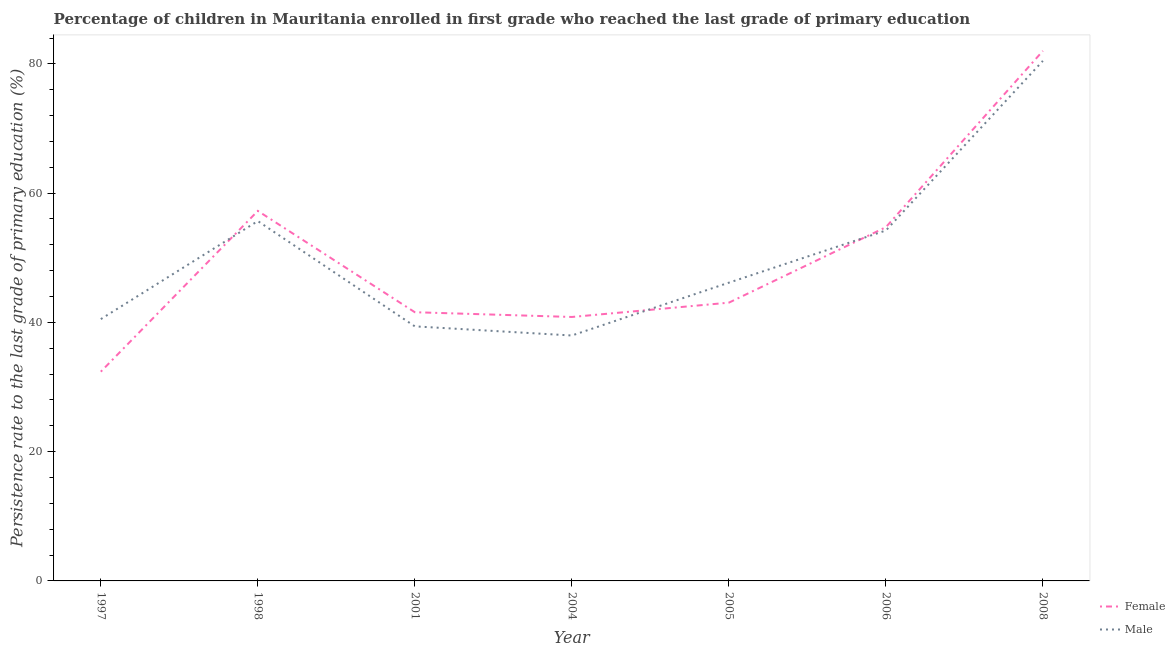What is the persistence rate of male students in 1997?
Make the answer very short. 40.51. Across all years, what is the maximum persistence rate of female students?
Your answer should be very brief. 82.01. Across all years, what is the minimum persistence rate of female students?
Your answer should be compact. 32.38. What is the total persistence rate of female students in the graph?
Your answer should be very brief. 351.83. What is the difference between the persistence rate of female students in 1998 and that in 2005?
Provide a short and direct response. 14.2. What is the difference between the persistence rate of female students in 1997 and the persistence rate of male students in 2008?
Ensure brevity in your answer.  -48.09. What is the average persistence rate of male students per year?
Offer a very short reply. 50.63. In the year 1997, what is the difference between the persistence rate of female students and persistence rate of male students?
Offer a terse response. -8.13. In how many years, is the persistence rate of female students greater than 28 %?
Your response must be concise. 7. What is the ratio of the persistence rate of male students in 1997 to that in 2006?
Offer a terse response. 0.75. Is the persistence rate of female students in 2005 less than that in 2006?
Your response must be concise. Yes. Is the difference between the persistence rate of male students in 2005 and 2006 greater than the difference between the persistence rate of female students in 2005 and 2006?
Provide a succinct answer. Yes. What is the difference between the highest and the second highest persistence rate of male students?
Make the answer very short. 24.79. What is the difference between the highest and the lowest persistence rate of male students?
Offer a terse response. 42.49. In how many years, is the persistence rate of female students greater than the average persistence rate of female students taken over all years?
Your answer should be very brief. 3. Does the persistence rate of male students monotonically increase over the years?
Provide a succinct answer. No. Is the persistence rate of male students strictly less than the persistence rate of female students over the years?
Your answer should be compact. No. How many lines are there?
Your answer should be compact. 2. How many years are there in the graph?
Give a very brief answer. 7. Does the graph contain any zero values?
Your response must be concise. No. Where does the legend appear in the graph?
Give a very brief answer. Bottom right. How are the legend labels stacked?
Your answer should be compact. Vertical. What is the title of the graph?
Your response must be concise. Percentage of children in Mauritania enrolled in first grade who reached the last grade of primary education. What is the label or title of the Y-axis?
Provide a succinct answer. Persistence rate to the last grade of primary education (%). What is the Persistence rate to the last grade of primary education (%) in Female in 1997?
Ensure brevity in your answer.  32.38. What is the Persistence rate to the last grade of primary education (%) of Male in 1997?
Ensure brevity in your answer.  40.51. What is the Persistence rate to the last grade of primary education (%) in Female in 1998?
Your response must be concise. 57.25. What is the Persistence rate to the last grade of primary education (%) in Male in 1998?
Your response must be concise. 55.68. What is the Persistence rate to the last grade of primary education (%) in Female in 2001?
Provide a succinct answer. 41.57. What is the Persistence rate to the last grade of primary education (%) in Male in 2001?
Make the answer very short. 39.39. What is the Persistence rate to the last grade of primary education (%) of Female in 2004?
Your response must be concise. 40.84. What is the Persistence rate to the last grade of primary education (%) in Male in 2004?
Give a very brief answer. 37.97. What is the Persistence rate to the last grade of primary education (%) in Female in 2005?
Provide a succinct answer. 43.05. What is the Persistence rate to the last grade of primary education (%) of Male in 2005?
Keep it short and to the point. 46.14. What is the Persistence rate to the last grade of primary education (%) of Female in 2006?
Offer a terse response. 54.73. What is the Persistence rate to the last grade of primary education (%) in Male in 2006?
Make the answer very short. 54.22. What is the Persistence rate to the last grade of primary education (%) in Female in 2008?
Give a very brief answer. 82.01. What is the Persistence rate to the last grade of primary education (%) of Male in 2008?
Your answer should be compact. 80.47. Across all years, what is the maximum Persistence rate to the last grade of primary education (%) of Female?
Make the answer very short. 82.01. Across all years, what is the maximum Persistence rate to the last grade of primary education (%) in Male?
Offer a very short reply. 80.47. Across all years, what is the minimum Persistence rate to the last grade of primary education (%) of Female?
Offer a terse response. 32.38. Across all years, what is the minimum Persistence rate to the last grade of primary education (%) of Male?
Offer a very short reply. 37.97. What is the total Persistence rate to the last grade of primary education (%) in Female in the graph?
Your answer should be very brief. 351.83. What is the total Persistence rate to the last grade of primary education (%) of Male in the graph?
Provide a succinct answer. 354.38. What is the difference between the Persistence rate to the last grade of primary education (%) in Female in 1997 and that in 1998?
Your answer should be very brief. -24.88. What is the difference between the Persistence rate to the last grade of primary education (%) in Male in 1997 and that in 1998?
Give a very brief answer. -15.17. What is the difference between the Persistence rate to the last grade of primary education (%) of Female in 1997 and that in 2001?
Give a very brief answer. -9.2. What is the difference between the Persistence rate to the last grade of primary education (%) in Male in 1997 and that in 2001?
Your answer should be compact. 1.12. What is the difference between the Persistence rate to the last grade of primary education (%) of Female in 1997 and that in 2004?
Make the answer very short. -8.46. What is the difference between the Persistence rate to the last grade of primary education (%) in Male in 1997 and that in 2004?
Keep it short and to the point. 2.54. What is the difference between the Persistence rate to the last grade of primary education (%) of Female in 1997 and that in 2005?
Give a very brief answer. -10.68. What is the difference between the Persistence rate to the last grade of primary education (%) in Male in 1997 and that in 2005?
Your response must be concise. -5.64. What is the difference between the Persistence rate to the last grade of primary education (%) of Female in 1997 and that in 2006?
Ensure brevity in your answer.  -22.36. What is the difference between the Persistence rate to the last grade of primary education (%) in Male in 1997 and that in 2006?
Keep it short and to the point. -13.71. What is the difference between the Persistence rate to the last grade of primary education (%) of Female in 1997 and that in 2008?
Offer a very short reply. -49.63. What is the difference between the Persistence rate to the last grade of primary education (%) in Male in 1997 and that in 2008?
Provide a short and direct response. -39.96. What is the difference between the Persistence rate to the last grade of primary education (%) in Female in 1998 and that in 2001?
Offer a very short reply. 15.68. What is the difference between the Persistence rate to the last grade of primary education (%) of Male in 1998 and that in 2001?
Your answer should be compact. 16.29. What is the difference between the Persistence rate to the last grade of primary education (%) in Female in 1998 and that in 2004?
Your response must be concise. 16.41. What is the difference between the Persistence rate to the last grade of primary education (%) in Male in 1998 and that in 2004?
Your answer should be very brief. 17.71. What is the difference between the Persistence rate to the last grade of primary education (%) of Female in 1998 and that in 2005?
Your response must be concise. 14.2. What is the difference between the Persistence rate to the last grade of primary education (%) of Male in 1998 and that in 2005?
Give a very brief answer. 9.53. What is the difference between the Persistence rate to the last grade of primary education (%) of Female in 1998 and that in 2006?
Your response must be concise. 2.52. What is the difference between the Persistence rate to the last grade of primary education (%) in Male in 1998 and that in 2006?
Your answer should be compact. 1.46. What is the difference between the Persistence rate to the last grade of primary education (%) of Female in 1998 and that in 2008?
Offer a terse response. -24.75. What is the difference between the Persistence rate to the last grade of primary education (%) of Male in 1998 and that in 2008?
Offer a very short reply. -24.79. What is the difference between the Persistence rate to the last grade of primary education (%) of Female in 2001 and that in 2004?
Provide a short and direct response. 0.74. What is the difference between the Persistence rate to the last grade of primary education (%) in Male in 2001 and that in 2004?
Offer a very short reply. 1.41. What is the difference between the Persistence rate to the last grade of primary education (%) in Female in 2001 and that in 2005?
Provide a succinct answer. -1.48. What is the difference between the Persistence rate to the last grade of primary education (%) in Male in 2001 and that in 2005?
Give a very brief answer. -6.76. What is the difference between the Persistence rate to the last grade of primary education (%) of Female in 2001 and that in 2006?
Make the answer very short. -13.16. What is the difference between the Persistence rate to the last grade of primary education (%) of Male in 2001 and that in 2006?
Keep it short and to the point. -14.83. What is the difference between the Persistence rate to the last grade of primary education (%) in Female in 2001 and that in 2008?
Your response must be concise. -40.43. What is the difference between the Persistence rate to the last grade of primary education (%) of Male in 2001 and that in 2008?
Keep it short and to the point. -41.08. What is the difference between the Persistence rate to the last grade of primary education (%) in Female in 2004 and that in 2005?
Your answer should be very brief. -2.21. What is the difference between the Persistence rate to the last grade of primary education (%) in Male in 2004 and that in 2005?
Keep it short and to the point. -8.17. What is the difference between the Persistence rate to the last grade of primary education (%) of Female in 2004 and that in 2006?
Keep it short and to the point. -13.89. What is the difference between the Persistence rate to the last grade of primary education (%) of Male in 2004 and that in 2006?
Offer a terse response. -16.25. What is the difference between the Persistence rate to the last grade of primary education (%) in Female in 2004 and that in 2008?
Provide a short and direct response. -41.17. What is the difference between the Persistence rate to the last grade of primary education (%) of Male in 2004 and that in 2008?
Your answer should be very brief. -42.49. What is the difference between the Persistence rate to the last grade of primary education (%) of Female in 2005 and that in 2006?
Give a very brief answer. -11.68. What is the difference between the Persistence rate to the last grade of primary education (%) of Male in 2005 and that in 2006?
Make the answer very short. -8.08. What is the difference between the Persistence rate to the last grade of primary education (%) in Female in 2005 and that in 2008?
Provide a short and direct response. -38.95. What is the difference between the Persistence rate to the last grade of primary education (%) of Male in 2005 and that in 2008?
Your response must be concise. -34.32. What is the difference between the Persistence rate to the last grade of primary education (%) of Female in 2006 and that in 2008?
Provide a succinct answer. -27.27. What is the difference between the Persistence rate to the last grade of primary education (%) of Male in 2006 and that in 2008?
Your response must be concise. -26.25. What is the difference between the Persistence rate to the last grade of primary education (%) of Female in 1997 and the Persistence rate to the last grade of primary education (%) of Male in 1998?
Your response must be concise. -23.3. What is the difference between the Persistence rate to the last grade of primary education (%) of Female in 1997 and the Persistence rate to the last grade of primary education (%) of Male in 2001?
Offer a very short reply. -7.01. What is the difference between the Persistence rate to the last grade of primary education (%) in Female in 1997 and the Persistence rate to the last grade of primary education (%) in Male in 2004?
Your answer should be compact. -5.6. What is the difference between the Persistence rate to the last grade of primary education (%) in Female in 1997 and the Persistence rate to the last grade of primary education (%) in Male in 2005?
Give a very brief answer. -13.77. What is the difference between the Persistence rate to the last grade of primary education (%) in Female in 1997 and the Persistence rate to the last grade of primary education (%) in Male in 2006?
Provide a succinct answer. -21.84. What is the difference between the Persistence rate to the last grade of primary education (%) of Female in 1997 and the Persistence rate to the last grade of primary education (%) of Male in 2008?
Your answer should be very brief. -48.09. What is the difference between the Persistence rate to the last grade of primary education (%) in Female in 1998 and the Persistence rate to the last grade of primary education (%) in Male in 2001?
Your answer should be very brief. 17.86. What is the difference between the Persistence rate to the last grade of primary education (%) in Female in 1998 and the Persistence rate to the last grade of primary education (%) in Male in 2004?
Keep it short and to the point. 19.28. What is the difference between the Persistence rate to the last grade of primary education (%) in Female in 1998 and the Persistence rate to the last grade of primary education (%) in Male in 2005?
Ensure brevity in your answer.  11.11. What is the difference between the Persistence rate to the last grade of primary education (%) of Female in 1998 and the Persistence rate to the last grade of primary education (%) of Male in 2006?
Offer a terse response. 3.03. What is the difference between the Persistence rate to the last grade of primary education (%) in Female in 1998 and the Persistence rate to the last grade of primary education (%) in Male in 2008?
Your response must be concise. -23.21. What is the difference between the Persistence rate to the last grade of primary education (%) in Female in 2001 and the Persistence rate to the last grade of primary education (%) in Male in 2004?
Offer a terse response. 3.6. What is the difference between the Persistence rate to the last grade of primary education (%) in Female in 2001 and the Persistence rate to the last grade of primary education (%) in Male in 2005?
Offer a terse response. -4.57. What is the difference between the Persistence rate to the last grade of primary education (%) in Female in 2001 and the Persistence rate to the last grade of primary education (%) in Male in 2006?
Your response must be concise. -12.65. What is the difference between the Persistence rate to the last grade of primary education (%) in Female in 2001 and the Persistence rate to the last grade of primary education (%) in Male in 2008?
Your answer should be very brief. -38.89. What is the difference between the Persistence rate to the last grade of primary education (%) of Female in 2004 and the Persistence rate to the last grade of primary education (%) of Male in 2005?
Provide a short and direct response. -5.31. What is the difference between the Persistence rate to the last grade of primary education (%) of Female in 2004 and the Persistence rate to the last grade of primary education (%) of Male in 2006?
Offer a terse response. -13.38. What is the difference between the Persistence rate to the last grade of primary education (%) in Female in 2004 and the Persistence rate to the last grade of primary education (%) in Male in 2008?
Your answer should be compact. -39.63. What is the difference between the Persistence rate to the last grade of primary education (%) in Female in 2005 and the Persistence rate to the last grade of primary education (%) in Male in 2006?
Ensure brevity in your answer.  -11.17. What is the difference between the Persistence rate to the last grade of primary education (%) in Female in 2005 and the Persistence rate to the last grade of primary education (%) in Male in 2008?
Provide a succinct answer. -37.41. What is the difference between the Persistence rate to the last grade of primary education (%) of Female in 2006 and the Persistence rate to the last grade of primary education (%) of Male in 2008?
Your answer should be very brief. -25.73. What is the average Persistence rate to the last grade of primary education (%) in Female per year?
Ensure brevity in your answer.  50.26. What is the average Persistence rate to the last grade of primary education (%) of Male per year?
Give a very brief answer. 50.63. In the year 1997, what is the difference between the Persistence rate to the last grade of primary education (%) of Female and Persistence rate to the last grade of primary education (%) of Male?
Your response must be concise. -8.13. In the year 1998, what is the difference between the Persistence rate to the last grade of primary education (%) in Female and Persistence rate to the last grade of primary education (%) in Male?
Your answer should be very brief. 1.57. In the year 2001, what is the difference between the Persistence rate to the last grade of primary education (%) of Female and Persistence rate to the last grade of primary education (%) of Male?
Your answer should be compact. 2.19. In the year 2004, what is the difference between the Persistence rate to the last grade of primary education (%) in Female and Persistence rate to the last grade of primary education (%) in Male?
Keep it short and to the point. 2.87. In the year 2005, what is the difference between the Persistence rate to the last grade of primary education (%) in Female and Persistence rate to the last grade of primary education (%) in Male?
Your answer should be compact. -3.09. In the year 2006, what is the difference between the Persistence rate to the last grade of primary education (%) of Female and Persistence rate to the last grade of primary education (%) of Male?
Make the answer very short. 0.51. In the year 2008, what is the difference between the Persistence rate to the last grade of primary education (%) in Female and Persistence rate to the last grade of primary education (%) in Male?
Your response must be concise. 1.54. What is the ratio of the Persistence rate to the last grade of primary education (%) of Female in 1997 to that in 1998?
Provide a succinct answer. 0.57. What is the ratio of the Persistence rate to the last grade of primary education (%) in Male in 1997 to that in 1998?
Offer a very short reply. 0.73. What is the ratio of the Persistence rate to the last grade of primary education (%) in Female in 1997 to that in 2001?
Make the answer very short. 0.78. What is the ratio of the Persistence rate to the last grade of primary education (%) in Male in 1997 to that in 2001?
Provide a succinct answer. 1.03. What is the ratio of the Persistence rate to the last grade of primary education (%) in Female in 1997 to that in 2004?
Keep it short and to the point. 0.79. What is the ratio of the Persistence rate to the last grade of primary education (%) in Male in 1997 to that in 2004?
Ensure brevity in your answer.  1.07. What is the ratio of the Persistence rate to the last grade of primary education (%) of Female in 1997 to that in 2005?
Your answer should be compact. 0.75. What is the ratio of the Persistence rate to the last grade of primary education (%) in Male in 1997 to that in 2005?
Make the answer very short. 0.88. What is the ratio of the Persistence rate to the last grade of primary education (%) of Female in 1997 to that in 2006?
Provide a succinct answer. 0.59. What is the ratio of the Persistence rate to the last grade of primary education (%) of Male in 1997 to that in 2006?
Your response must be concise. 0.75. What is the ratio of the Persistence rate to the last grade of primary education (%) in Female in 1997 to that in 2008?
Your answer should be compact. 0.39. What is the ratio of the Persistence rate to the last grade of primary education (%) in Male in 1997 to that in 2008?
Your response must be concise. 0.5. What is the ratio of the Persistence rate to the last grade of primary education (%) in Female in 1998 to that in 2001?
Offer a very short reply. 1.38. What is the ratio of the Persistence rate to the last grade of primary education (%) in Male in 1998 to that in 2001?
Provide a short and direct response. 1.41. What is the ratio of the Persistence rate to the last grade of primary education (%) in Female in 1998 to that in 2004?
Provide a short and direct response. 1.4. What is the ratio of the Persistence rate to the last grade of primary education (%) of Male in 1998 to that in 2004?
Provide a succinct answer. 1.47. What is the ratio of the Persistence rate to the last grade of primary education (%) in Female in 1998 to that in 2005?
Your response must be concise. 1.33. What is the ratio of the Persistence rate to the last grade of primary education (%) of Male in 1998 to that in 2005?
Give a very brief answer. 1.21. What is the ratio of the Persistence rate to the last grade of primary education (%) in Female in 1998 to that in 2006?
Make the answer very short. 1.05. What is the ratio of the Persistence rate to the last grade of primary education (%) in Male in 1998 to that in 2006?
Provide a short and direct response. 1.03. What is the ratio of the Persistence rate to the last grade of primary education (%) of Female in 1998 to that in 2008?
Provide a succinct answer. 0.7. What is the ratio of the Persistence rate to the last grade of primary education (%) in Male in 1998 to that in 2008?
Your answer should be compact. 0.69. What is the ratio of the Persistence rate to the last grade of primary education (%) in Female in 2001 to that in 2004?
Offer a very short reply. 1.02. What is the ratio of the Persistence rate to the last grade of primary education (%) of Male in 2001 to that in 2004?
Provide a succinct answer. 1.04. What is the ratio of the Persistence rate to the last grade of primary education (%) in Female in 2001 to that in 2005?
Keep it short and to the point. 0.97. What is the ratio of the Persistence rate to the last grade of primary education (%) of Male in 2001 to that in 2005?
Make the answer very short. 0.85. What is the ratio of the Persistence rate to the last grade of primary education (%) in Female in 2001 to that in 2006?
Offer a terse response. 0.76. What is the ratio of the Persistence rate to the last grade of primary education (%) in Male in 2001 to that in 2006?
Your answer should be very brief. 0.73. What is the ratio of the Persistence rate to the last grade of primary education (%) in Female in 2001 to that in 2008?
Ensure brevity in your answer.  0.51. What is the ratio of the Persistence rate to the last grade of primary education (%) of Male in 2001 to that in 2008?
Give a very brief answer. 0.49. What is the ratio of the Persistence rate to the last grade of primary education (%) of Female in 2004 to that in 2005?
Offer a very short reply. 0.95. What is the ratio of the Persistence rate to the last grade of primary education (%) in Male in 2004 to that in 2005?
Keep it short and to the point. 0.82. What is the ratio of the Persistence rate to the last grade of primary education (%) in Female in 2004 to that in 2006?
Your answer should be very brief. 0.75. What is the ratio of the Persistence rate to the last grade of primary education (%) of Male in 2004 to that in 2006?
Keep it short and to the point. 0.7. What is the ratio of the Persistence rate to the last grade of primary education (%) in Female in 2004 to that in 2008?
Ensure brevity in your answer.  0.5. What is the ratio of the Persistence rate to the last grade of primary education (%) of Male in 2004 to that in 2008?
Your response must be concise. 0.47. What is the ratio of the Persistence rate to the last grade of primary education (%) in Female in 2005 to that in 2006?
Provide a succinct answer. 0.79. What is the ratio of the Persistence rate to the last grade of primary education (%) of Male in 2005 to that in 2006?
Make the answer very short. 0.85. What is the ratio of the Persistence rate to the last grade of primary education (%) of Female in 2005 to that in 2008?
Your answer should be compact. 0.53. What is the ratio of the Persistence rate to the last grade of primary education (%) of Male in 2005 to that in 2008?
Your answer should be very brief. 0.57. What is the ratio of the Persistence rate to the last grade of primary education (%) of Female in 2006 to that in 2008?
Provide a short and direct response. 0.67. What is the ratio of the Persistence rate to the last grade of primary education (%) of Male in 2006 to that in 2008?
Your response must be concise. 0.67. What is the difference between the highest and the second highest Persistence rate to the last grade of primary education (%) in Female?
Provide a succinct answer. 24.75. What is the difference between the highest and the second highest Persistence rate to the last grade of primary education (%) of Male?
Your answer should be very brief. 24.79. What is the difference between the highest and the lowest Persistence rate to the last grade of primary education (%) of Female?
Your response must be concise. 49.63. What is the difference between the highest and the lowest Persistence rate to the last grade of primary education (%) of Male?
Offer a very short reply. 42.49. 